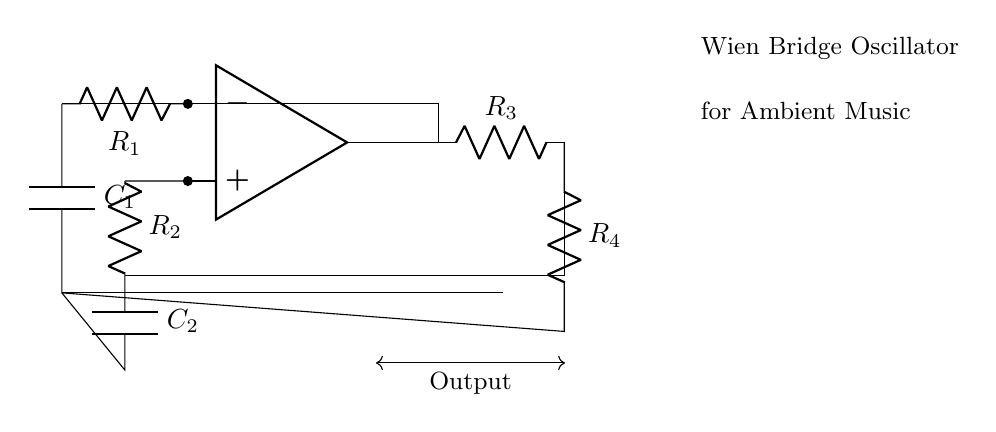what type of oscillator is depicted in this circuit? The circuit is labeled as a Wien Bridge Oscillator, which is a specific type of electronic oscillator that generates sine waves. The designation is clearly shown in the node notes.
Answer: Wien Bridge Oscillator how many resistors are present in this circuit? The circuit diagram shows four resistors (R1, R2, R3, R4). Each is clearly labeled and connected in the configuration that is characteristic of a Wien Bridge Oscillator.
Answer: 4 what is the role of the op-amp in this oscillator? The operational amplifier (op-amp) serves as an amplifier to produce oscillations by providing the necessary gain for the feedback loop. Its role is central to the working of the oscillator, aiding in generating the desired frequency.
Answer: Amplification what is the purpose of the capacitors in this circuit? The capacitors (C1 and C2) are used to set the frequency of oscillation along with the resistors. They provide the necessary phase shift in the feedback loop that is crucial for sustained oscillation.
Answer: Frequency setting how does feedback occur in this Wien Bridge Oscillator circuit? Feedback occurs through the connection between the output of the op-amp and the input resistor (R1) through the output resistor (R3). This feedback is essential to maintain oscillation by providing a portion of the output signal back to the input with the correct phase.
Answer: Through R1 and R3 what determines the frequency of the output signal from this oscillator? The frequency of the output signal is determined by the values of the resistors (R1, R2, R3, R4) and the capacitors (C1, C2). These components form a specific network that dictates the oscillation frequency based on the formula related to the resistors and capacitors involved.
Answer: R1, R2, C1, C2 